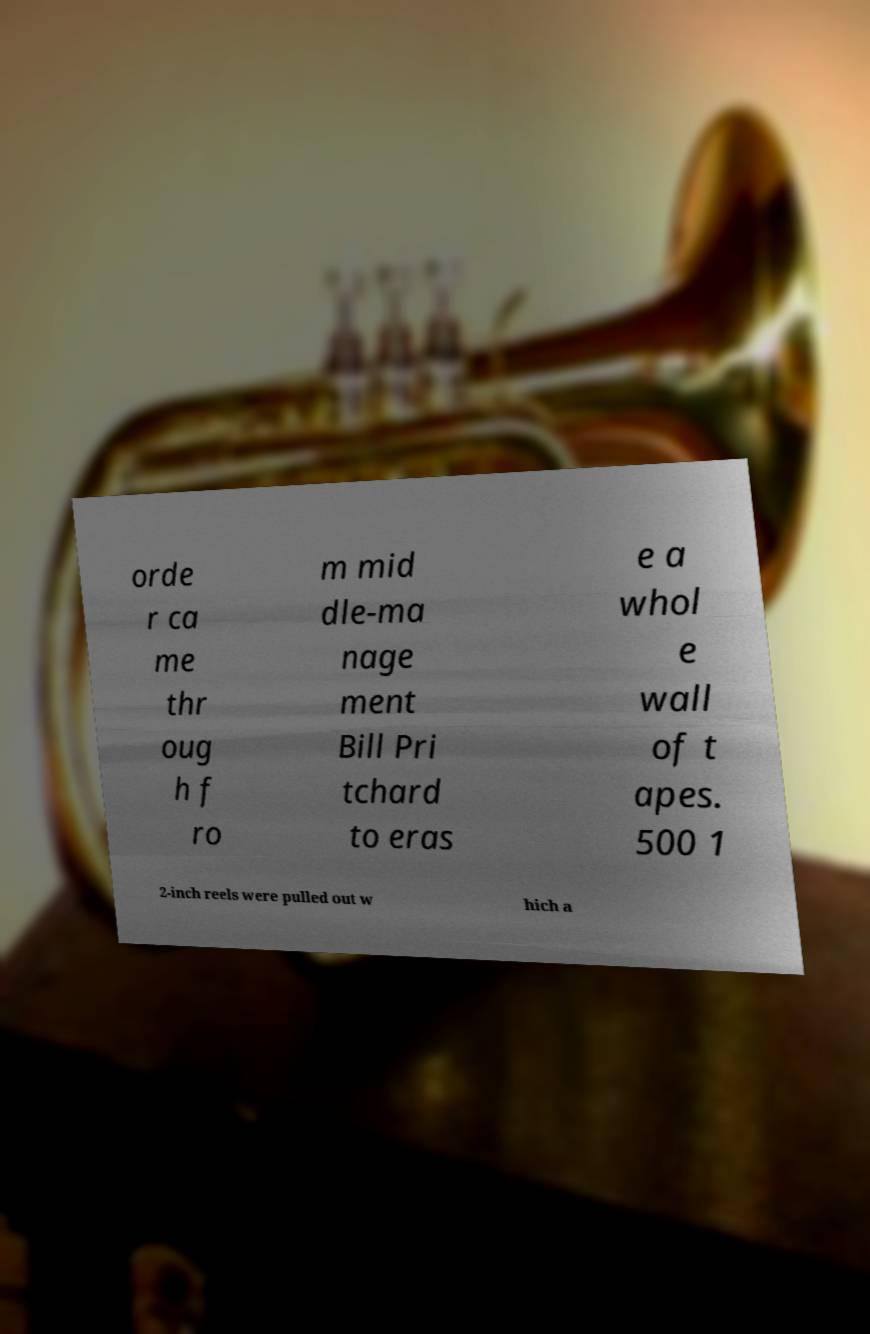Can you accurately transcribe the text from the provided image for me? orde r ca me thr oug h f ro m mid dle-ma nage ment Bill Pri tchard to eras e a whol e wall of t apes. 500 1 2-inch reels were pulled out w hich a 